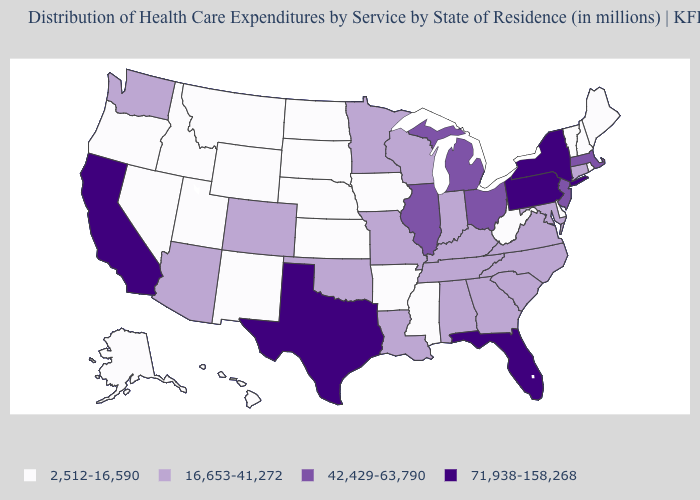What is the value of Wisconsin?
Keep it brief. 16,653-41,272. What is the value of Pennsylvania?
Concise answer only. 71,938-158,268. Is the legend a continuous bar?
Concise answer only. No. Does Arkansas have a lower value than Alabama?
Short answer required. Yes. What is the highest value in the South ?
Keep it brief. 71,938-158,268. How many symbols are there in the legend?
Write a very short answer. 4. Does the first symbol in the legend represent the smallest category?
Be succinct. Yes. Name the states that have a value in the range 16,653-41,272?
Short answer required. Alabama, Arizona, Colorado, Connecticut, Georgia, Indiana, Kentucky, Louisiana, Maryland, Minnesota, Missouri, North Carolina, Oklahoma, South Carolina, Tennessee, Virginia, Washington, Wisconsin. Does the map have missing data?
Concise answer only. No. Does North Carolina have a lower value than South Carolina?
Concise answer only. No. What is the highest value in the MidWest ?
Write a very short answer. 42,429-63,790. Is the legend a continuous bar?
Answer briefly. No. Which states hav the highest value in the MidWest?
Write a very short answer. Illinois, Michigan, Ohio. Among the states that border Arkansas , which have the lowest value?
Write a very short answer. Mississippi. What is the highest value in states that border Maryland?
Quick response, please. 71,938-158,268. 